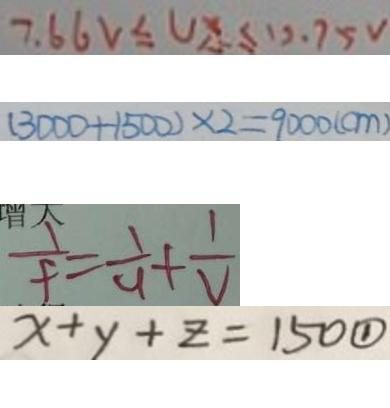<formula> <loc_0><loc_0><loc_500><loc_500>7 . 6 6 V \leq U x \leq 1 2 . 7 5 V 
 ( 3 0 0 0 + 1 5 0 0 ) \times 2 = 9 0 0 0 ( c m ) 
 \frac { 1 } { f } = \frac { 1 } { 4 } + \frac { 1 } { V } 
 x + y + z = 1 5 0 \textcircled { 1 }</formula> 